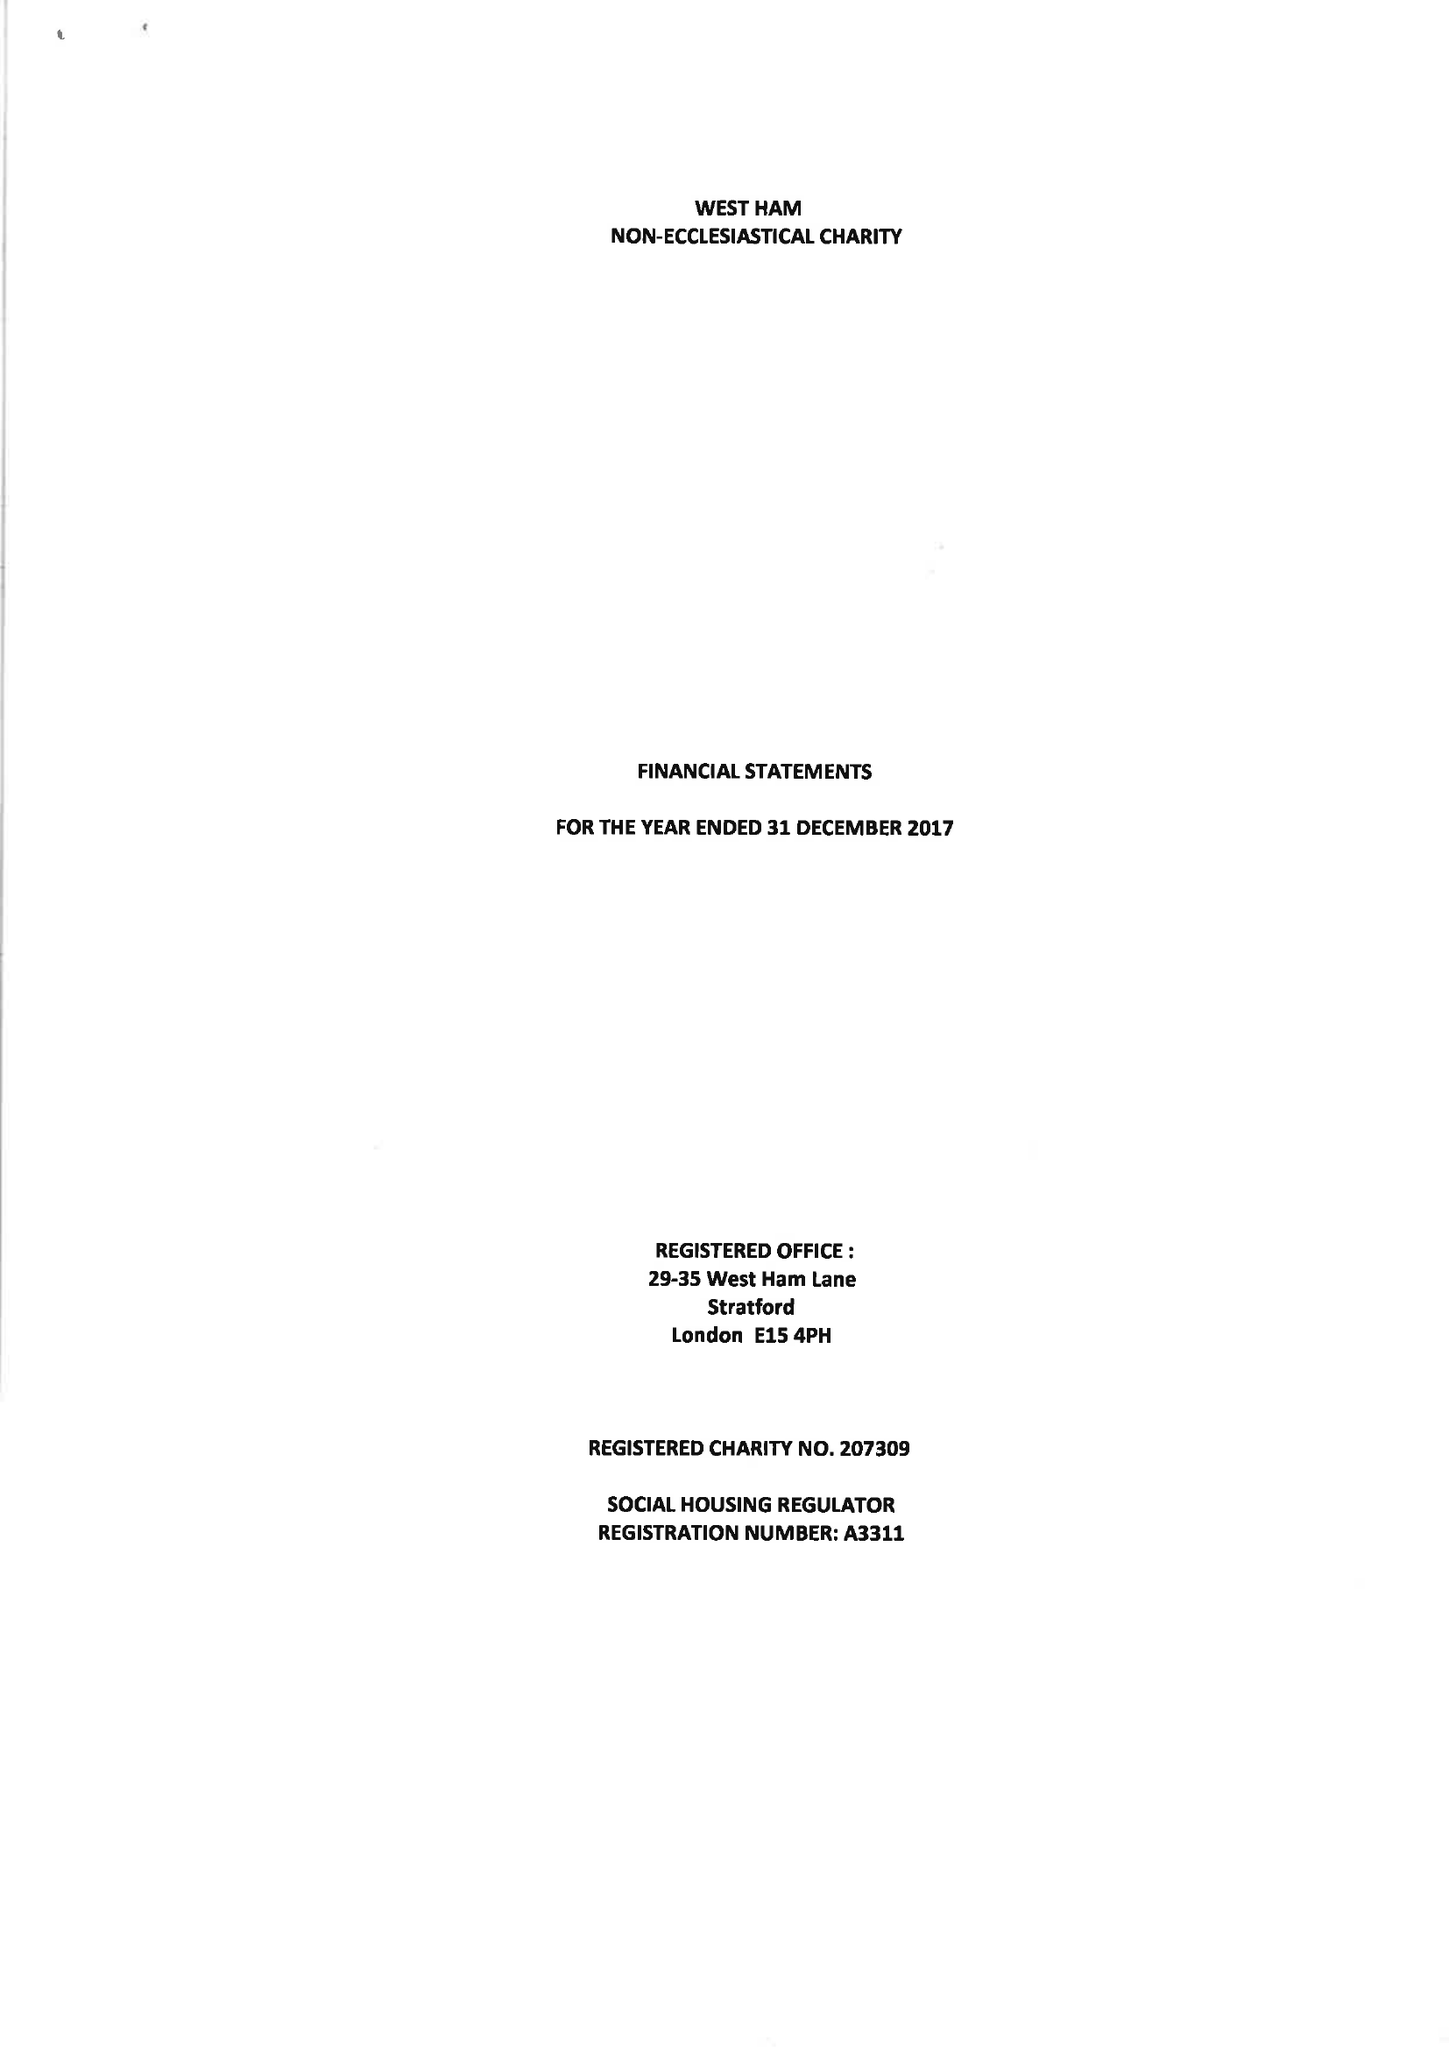What is the value for the address__postcode?
Answer the question using a single word or phrase. E15 4PH 